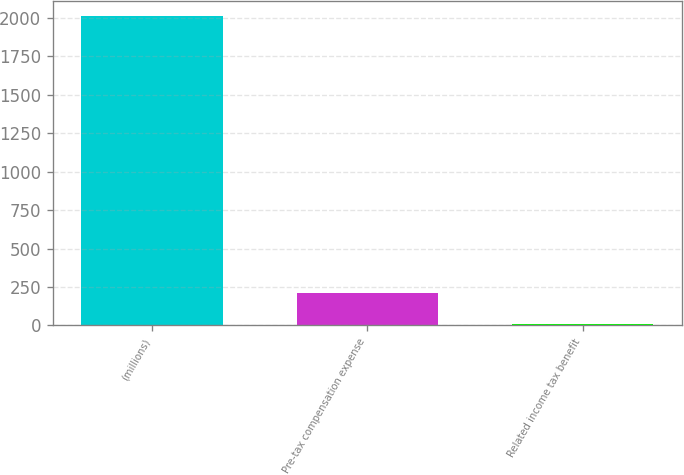Convert chart to OTSL. <chart><loc_0><loc_0><loc_500><loc_500><bar_chart><fcel>(millions)<fcel>Pre-tax compensation expense<fcel>Related income tax benefit<nl><fcel>2010<fcel>210<fcel>10<nl></chart> 